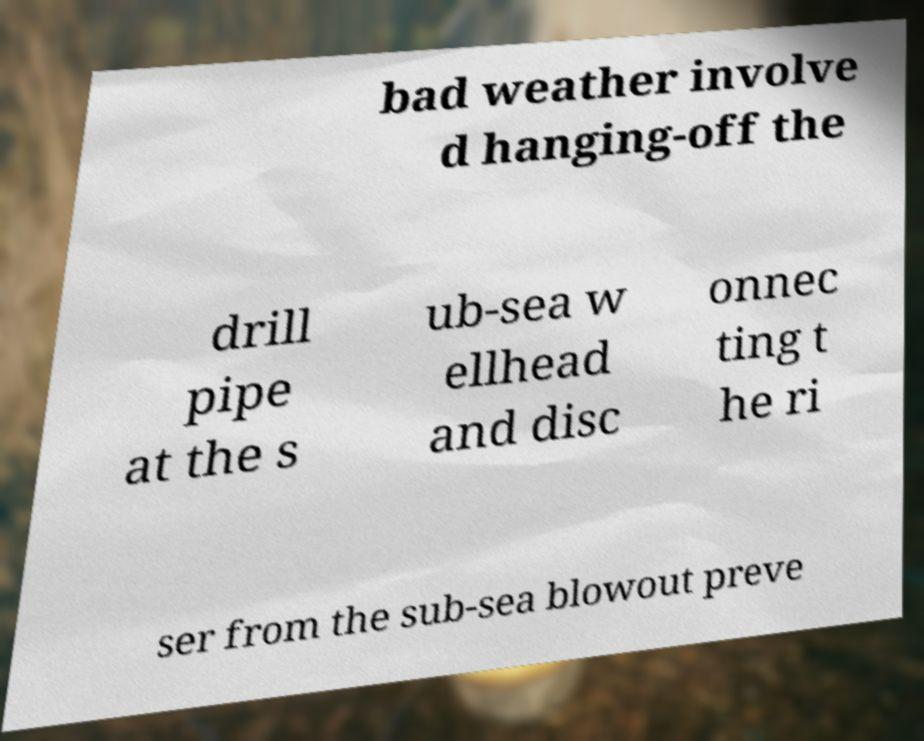There's text embedded in this image that I need extracted. Can you transcribe it verbatim? bad weather involve d hanging-off the drill pipe at the s ub-sea w ellhead and disc onnec ting t he ri ser from the sub-sea blowout preve 